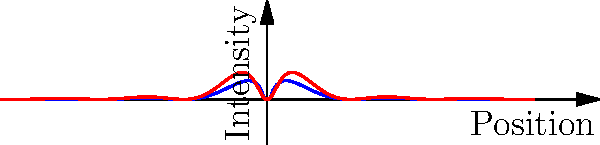In crafting a speech about scientific innovation, you want to emphasize the importance of understanding fundamental physics principles. How would you explain the key difference between single-slit and double-slit diffraction patterns, as shown in the graph, to illustrate the wave nature of light in a way that resonates with policymakers focused on technological advancement? To explain the difference between single-slit and double-slit diffraction patterns to policymakers, we can break it down into steps:

1. Single-slit diffraction (blue curve):
   - When light passes through a single narrow slit, it spreads out.
   - The resulting pattern shows a central bright maximum with alternating dim and bright fringes on either side.
   - The intensity decreases rapidly as we move away from the center.
   - This demonstrates the wave nature of light, as particles wouldn't behave this way.

2. Double-slit interference (red curve):
   - When light passes through two narrow slits, we see a more complex pattern.
   - The overall envelope is similar to the single-slit pattern.
   - However, within this envelope, we see rapid oscillations between bright and dark fringes.
   - These oscillations are due to interference between waves from the two slits.

3. Key differences:
   - The double-slit pattern has more frequent intensity variations.
   - The double-slit pattern demonstrates both diffraction (spreading of light) and interference (interaction between waves).

4. Significance for policymakers:
   - This phenomenon underpins many modern technologies, including:
     a) High-resolution imaging in medicine and astronomy
     b) Optical communication systems
     c) Nanofabrication techniques

5. Technological implications:
   - Understanding these patterns allows for the development of more precise optical instruments.
   - It's crucial for advancements in fields like quantum computing and nanotechnology.

6. Policy relevance:
   - Investing in fundamental physics research can lead to unforeseen technological breakthroughs.
   - Supporting education and research in these areas can drive innovation and economic growth.
Answer: The key difference is that double-slit patterns show rapid intensity oscillations due to wave interference, while single-slit patterns only show diffraction, illustrating light's wave nature and its importance in advancing optical technologies. 